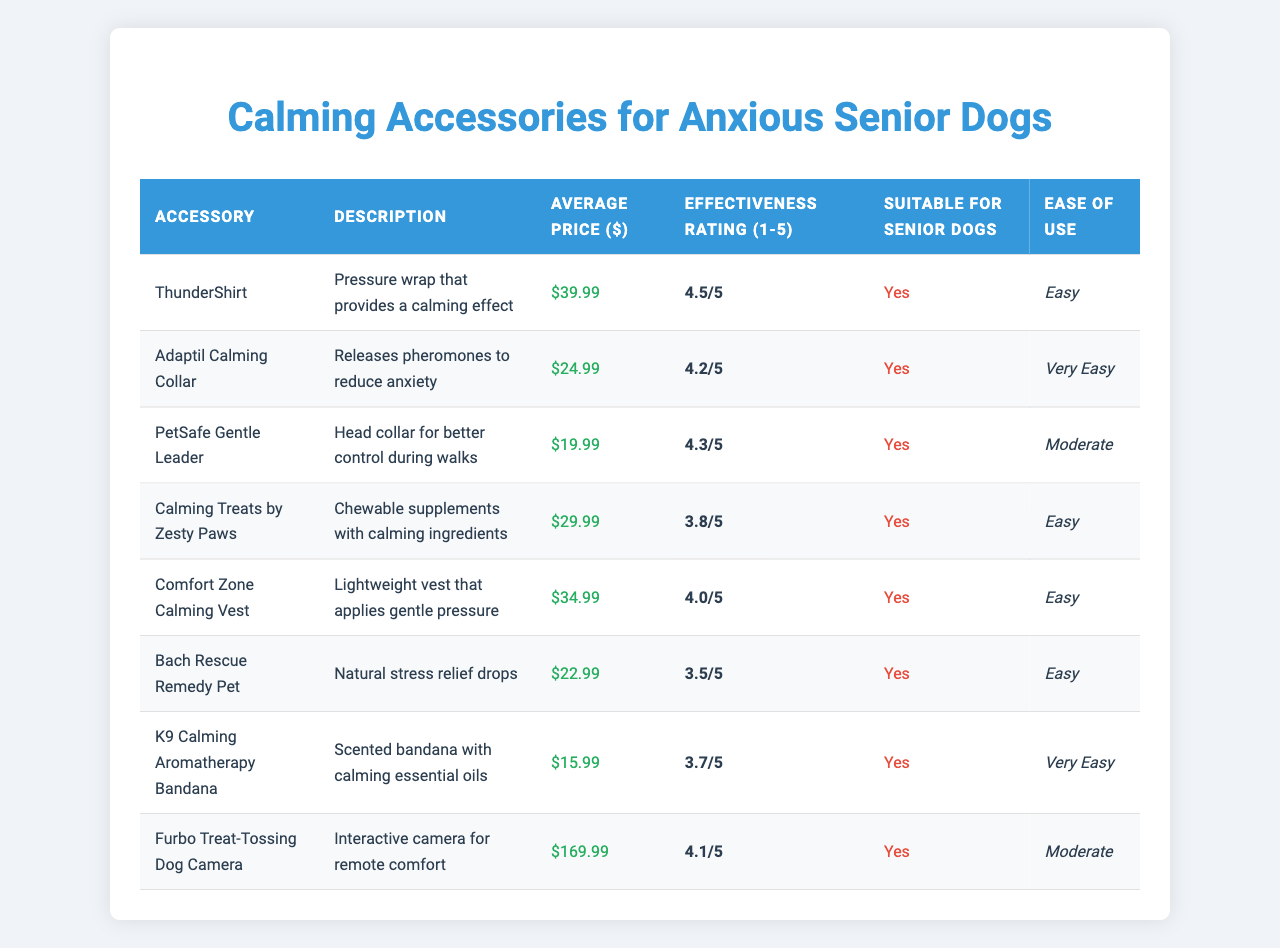What is the effectiveness rating of the ThunderShirt? Looking at the table, the ThunderShirt has an effectiveness rating listed as 4.5 out of 5.
Answer: 4.5 Which accessory has the lowest average price? Scanning through the prices in the table, the K9 Calming Aromatherapy Bandana is priced at $15.99, which is the lowest price listed.
Answer: $15.99 Are all the accessories suitable for senior dogs? The table indicates "Yes" in the "Suitable for Senior Dogs" column for every accessory listed, confirming that they are all suitable.
Answer: Yes What is the price difference between the Furbo Treat-Tossing Dog Camera and the Adaptil Calming Collar? The price of the Furbo Treat-Tossing Dog Camera is $169.99 and the price of the Adaptil Calming Collar is $24.99. The difference is $169.99 - $24.99 = $145.00.
Answer: $145.00 Which accessory has the highest effectiveness rating? The ThunderShirt has the highest effectiveness rating of 4.5, making it the most effective option compared to others in the table.
Answer: ThunderShirt What is the average effectiveness rating of all the accessories listed? Adding the effectiveness ratings: 4.5 + 4.2 + 4.3 + 3.8 + 4.0 + 3.5 + 3.7 + 4.1 = 32.1. There are 8 accessories, so the average is 32.1 / 8 = 4.0125, which rounds to approximately 4.01.
Answer: 4.01 Is the Comfort Zone Calming Vest easier to use than the PetSafe Gentle Leader? The table shows that the Comfort Zone Calming Vest has "Easy" in the "Ease of Use" column, while the PetSafe Gentle Leader is rated as "Moderate," indicating it is easier to use.
Answer: Yes Which accessory combines calming effects with a collar design? The Adaptil Calming Collar specifically combines calming pheromones and a collar format, fulfilling both criteria from the question.
Answer: Adaptil Calming Collar How many accessories have an effectiveness rating of 4 or higher? The effectiveness ratings that are 4 or above are: ThunderShirt (4.5), Adaptil Calming Collar (4.2), PetSafe Gentle Leader (4.3), Comfort Zone Calming Vest (4.0), and Furbo Treat-Tossing Dog Camera (4.1). That gives us 5 accessories with ratings of 4 or higher.
Answer: 5 What percentage of the accessories are classified as "Very Easy" to use? Out of 8 total accessories, 2 (Adaptil Calming Collar and K9 Calming Aromatherapy Bandana) are classified as "Very Easy." Therefore, (2/8) * 100% = 25%.
Answer: 25% 